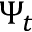<formula> <loc_0><loc_0><loc_500><loc_500>\Psi _ { t }</formula> 